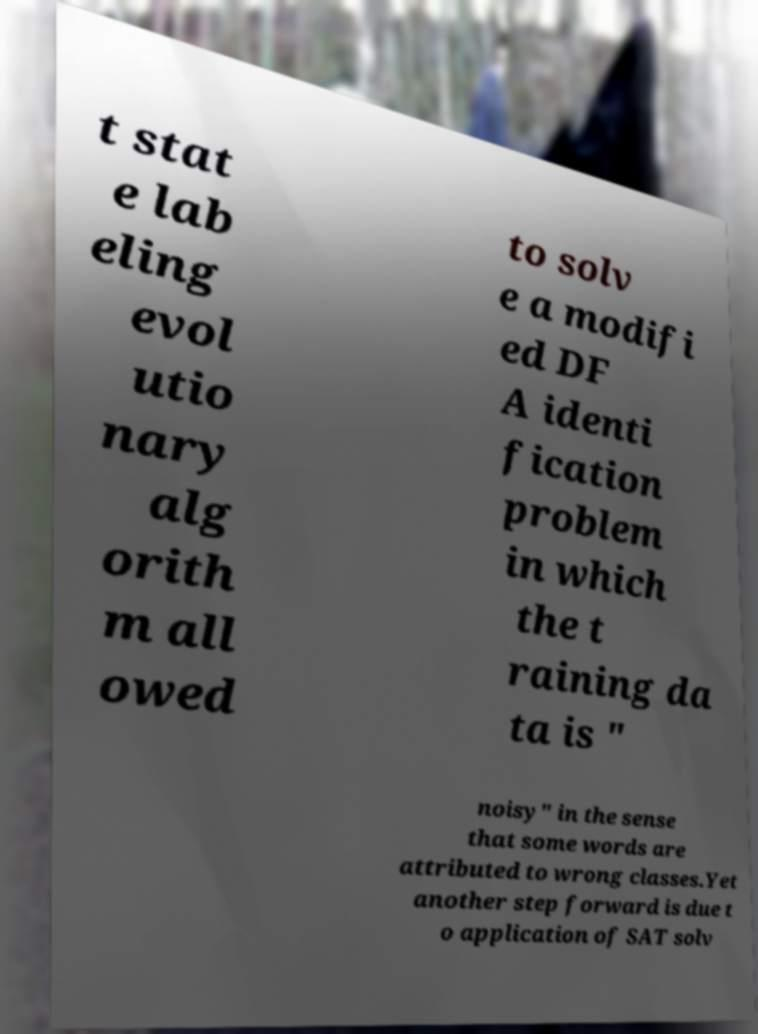There's text embedded in this image that I need extracted. Can you transcribe it verbatim? t stat e lab eling evol utio nary alg orith m all owed to solv e a modifi ed DF A identi fication problem in which the t raining da ta is " noisy" in the sense that some words are attributed to wrong classes.Yet another step forward is due t o application of SAT solv 